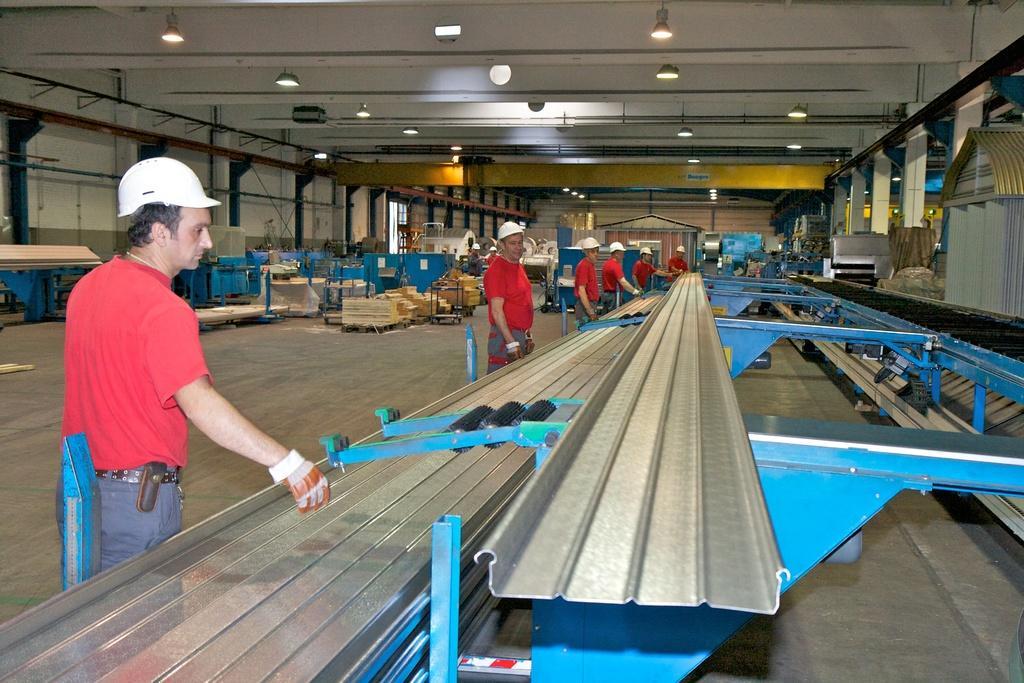How would you summarize this image in a sentence or two? This image consists of machines and there are many persons, wearing red t-shirts and caps. At the top, there is a roof along with the lights. At the bottom, there is a floor. 